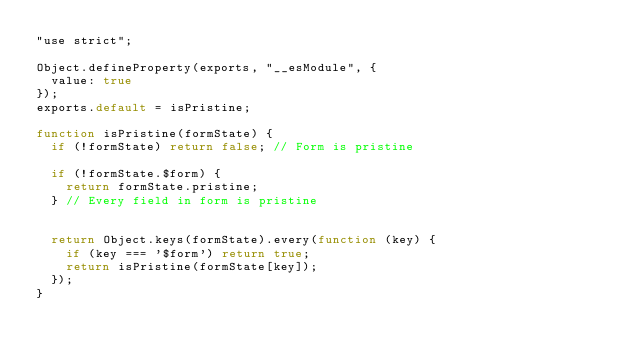<code> <loc_0><loc_0><loc_500><loc_500><_JavaScript_>"use strict";

Object.defineProperty(exports, "__esModule", {
  value: true
});
exports.default = isPristine;

function isPristine(formState) {
  if (!formState) return false; // Form is pristine

  if (!formState.$form) {
    return formState.pristine;
  } // Every field in form is pristine


  return Object.keys(formState).every(function (key) {
    if (key === '$form') return true;
    return isPristine(formState[key]);
  });
}</code> 